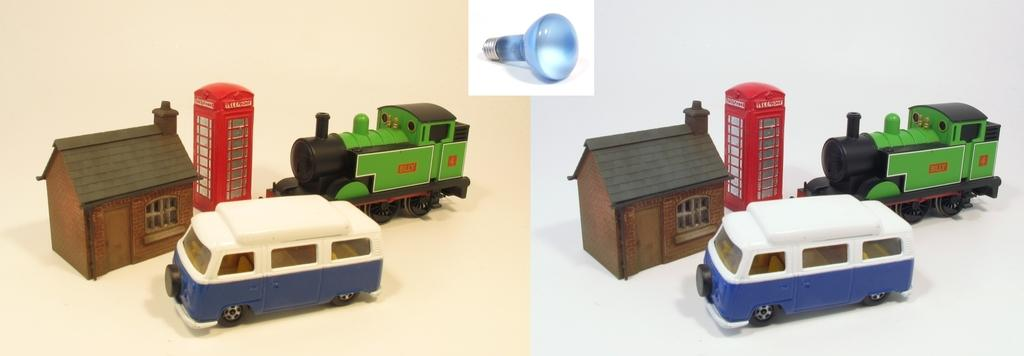What type of image is shown in the picture? The image is a collage of two pictures. What objects can be seen in the collage? There are toys in the image, including a house, booth, train, and car. Can you identify any other objects in the image? Yes, there is a bulb in the image. How does the ocean affect the force of the waves in the image? There is no ocean present in the image, so it is not possible to determine how the ocean might affect the force of the waves. 